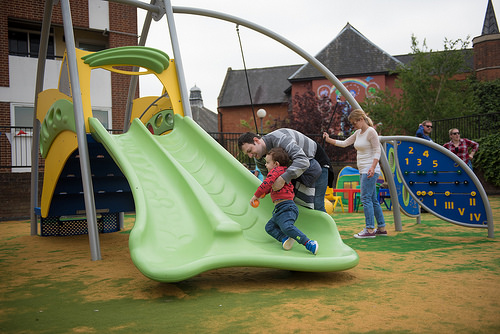<image>
Is there a child under the man? No. The child is not positioned under the man. The vertical relationship between these objects is different. 